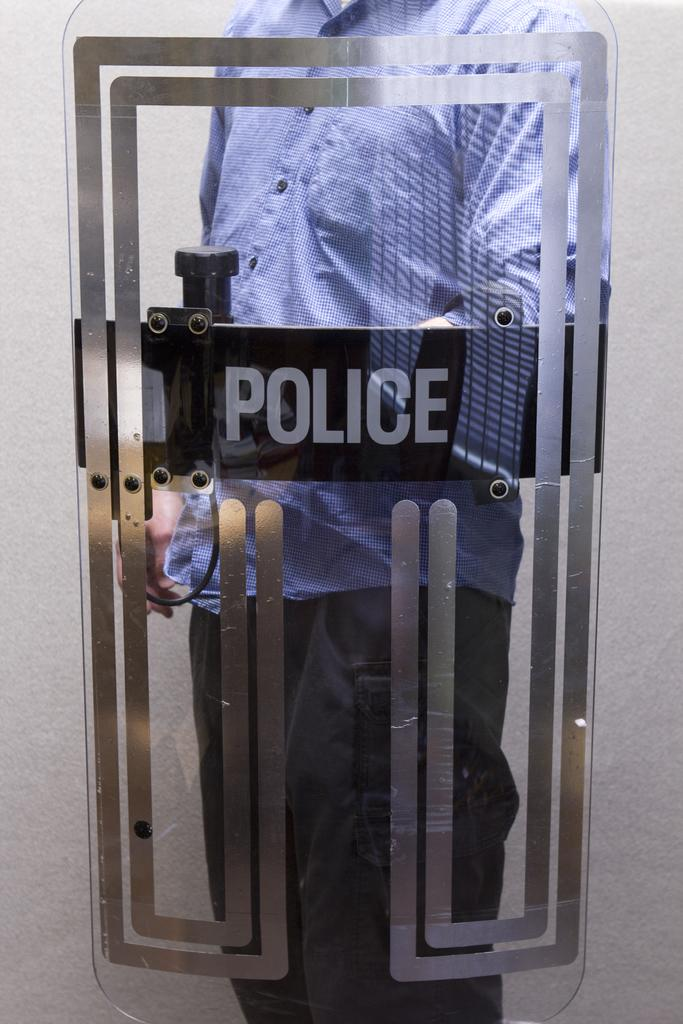What is the main subject of the image? There is a person in the image. What is the person holding in the image? The person is holding a police shield. What type of crack is visible on the person's cap in the image? There is no cap or crack present in the image; the person is holding a police shield. 